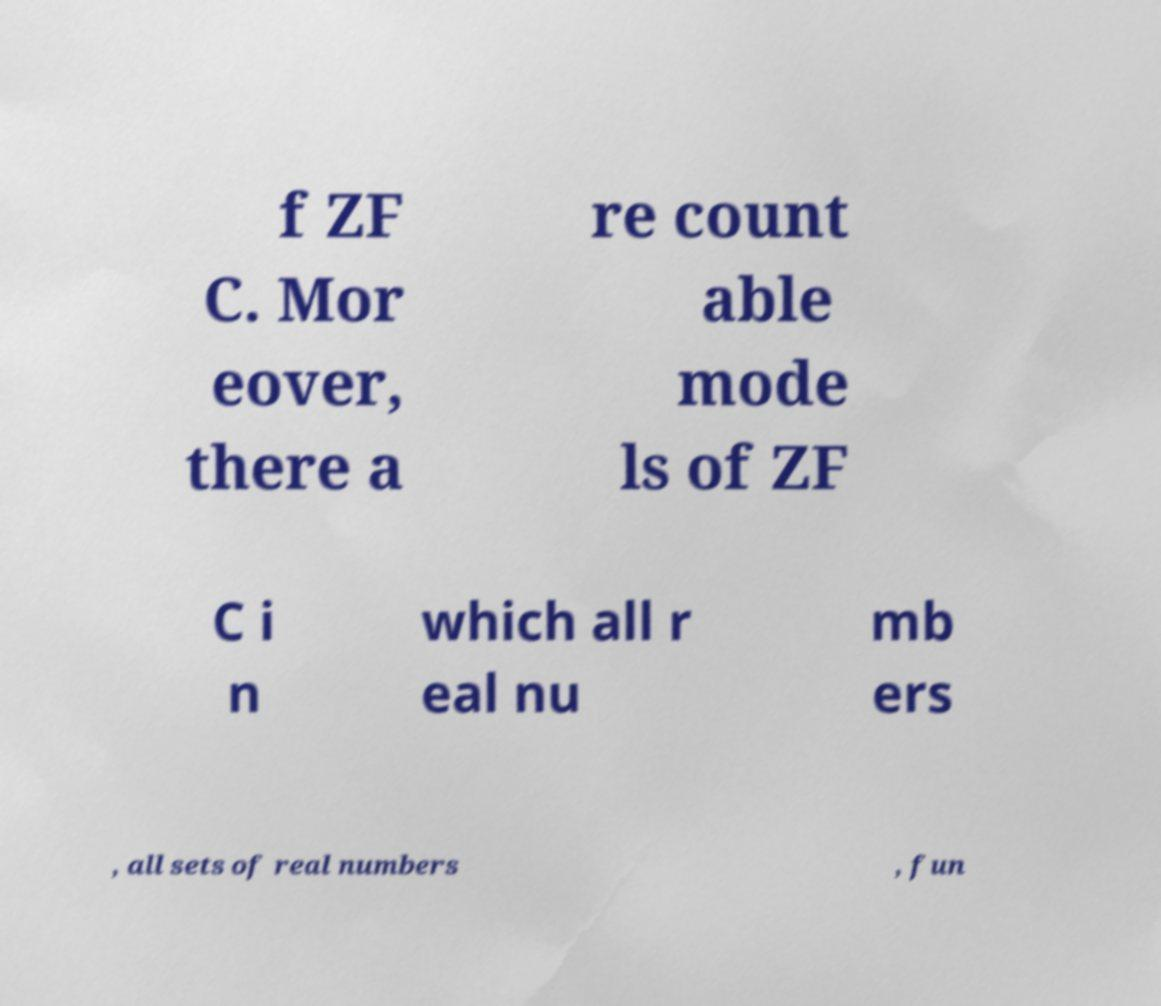Please read and relay the text visible in this image. What does it say? f ZF C. Mor eover, there a re count able mode ls of ZF C i n which all r eal nu mb ers , all sets of real numbers , fun 